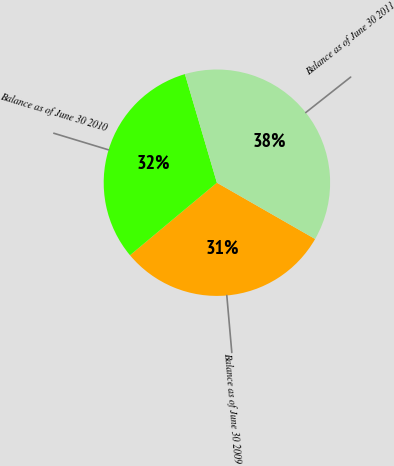Convert chart to OTSL. <chart><loc_0><loc_0><loc_500><loc_500><pie_chart><fcel>Balance as of June 30 2009<fcel>Balance as of June 30 2010<fcel>Balance as of June 30 2011<nl><fcel>30.65%<fcel>31.51%<fcel>37.84%<nl></chart> 